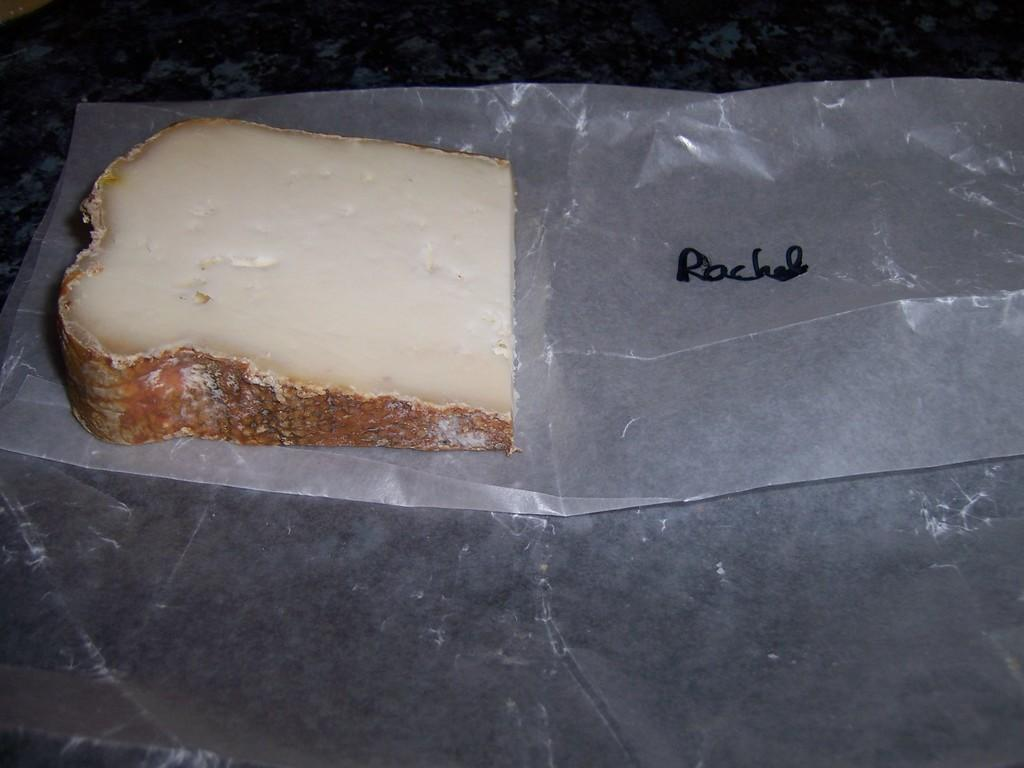What type of food can be seen in the image? There are cheese slices in the image. What object is on the table in the image? There is a cover on the table in the image. Where was the image taken? The image was taken in a room. What type of shirt is being worn by the stream in the image? There is no stream or shirt present in the image; it only features cheese slices and a cover on a table in a room. 